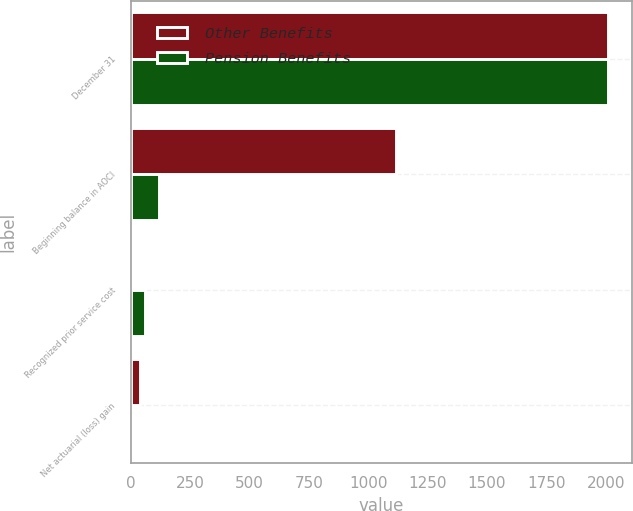<chart> <loc_0><loc_0><loc_500><loc_500><stacked_bar_chart><ecel><fcel>December 31<fcel>Beginning balance in AOCI<fcel>Recognized prior service cost<fcel>Net actuarial (loss) gain<nl><fcel>Other Benefits<fcel>2010<fcel>1119<fcel>5<fcel>41<nl><fcel>Pension Benefits<fcel>2010<fcel>118<fcel>61<fcel>8<nl></chart> 